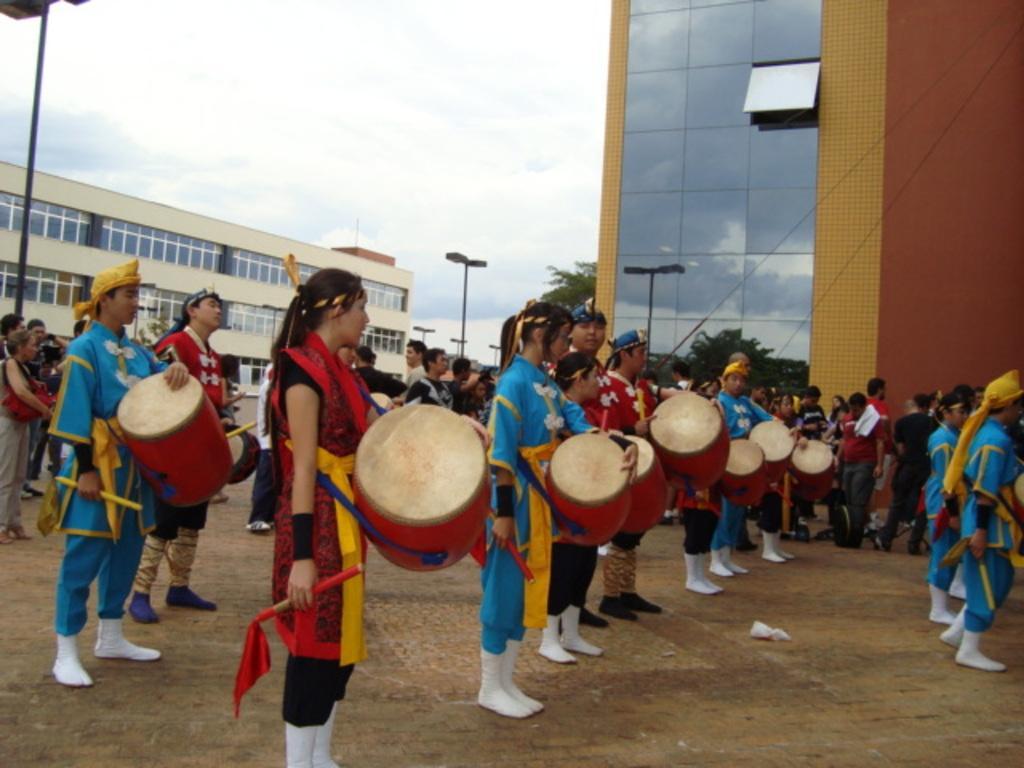How would you summarize this image in a sentence or two? In this image i can see few people playing musical instrument at the back ground i can see a building , a pole and a sky. 